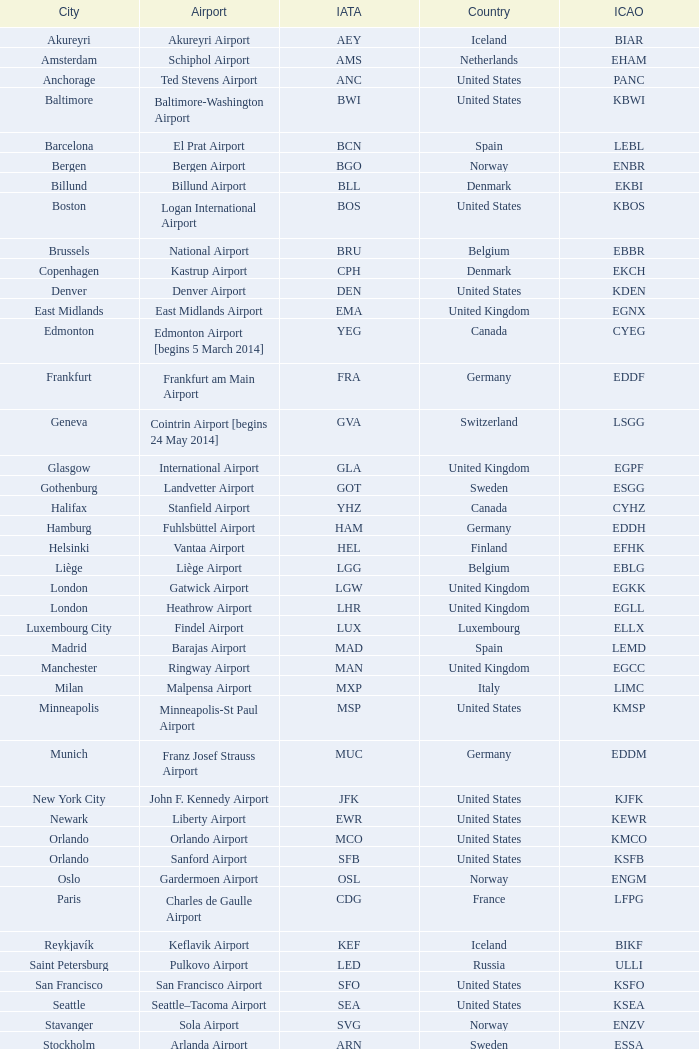What is the Airport with the ICAO fo KSEA? Seattle–Tacoma Airport. 